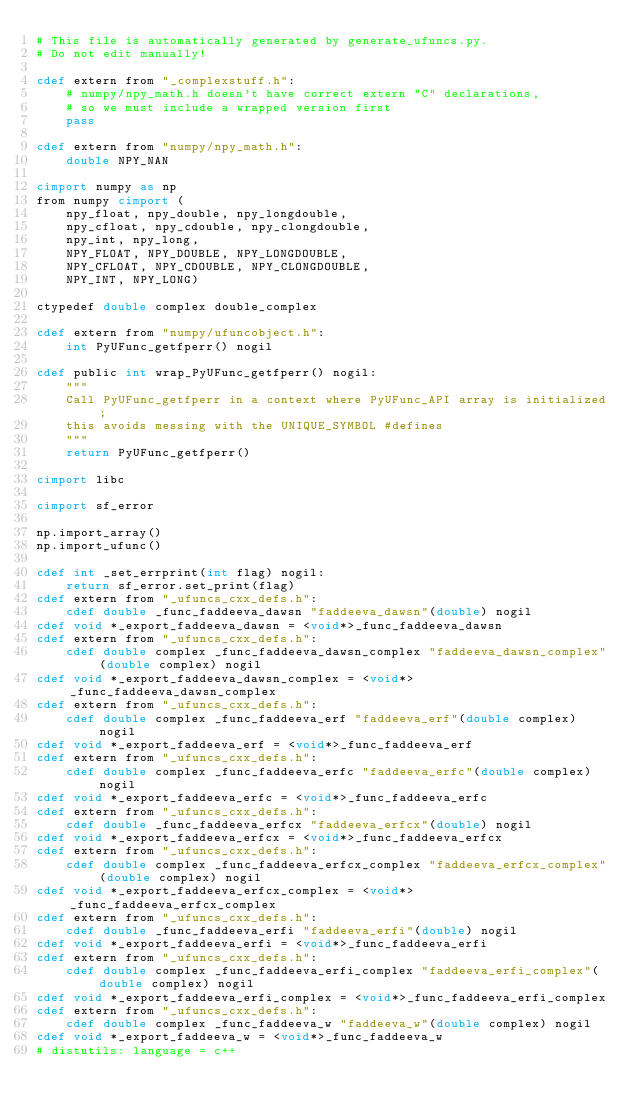<code> <loc_0><loc_0><loc_500><loc_500><_Cython_># This file is automatically generated by generate_ufuncs.py.
# Do not edit manually!

cdef extern from "_complexstuff.h":
    # numpy/npy_math.h doesn't have correct extern "C" declarations,
    # so we must include a wrapped version first
    pass

cdef extern from "numpy/npy_math.h":
    double NPY_NAN

cimport numpy as np
from numpy cimport (
    npy_float, npy_double, npy_longdouble,
    npy_cfloat, npy_cdouble, npy_clongdouble,
    npy_int, npy_long,
    NPY_FLOAT, NPY_DOUBLE, NPY_LONGDOUBLE,
    NPY_CFLOAT, NPY_CDOUBLE, NPY_CLONGDOUBLE,
    NPY_INT, NPY_LONG)

ctypedef double complex double_complex

cdef extern from "numpy/ufuncobject.h":
    int PyUFunc_getfperr() nogil

cdef public int wrap_PyUFunc_getfperr() nogil:
    """
    Call PyUFunc_getfperr in a context where PyUFunc_API array is initialized;
    this avoids messing with the UNIQUE_SYMBOL #defines
    """
    return PyUFunc_getfperr()

cimport libc

cimport sf_error

np.import_array()
np.import_ufunc()

cdef int _set_errprint(int flag) nogil:
    return sf_error.set_print(flag)
cdef extern from "_ufuncs_cxx_defs.h":
    cdef double _func_faddeeva_dawsn "faddeeva_dawsn"(double) nogil
cdef void *_export_faddeeva_dawsn = <void*>_func_faddeeva_dawsn
cdef extern from "_ufuncs_cxx_defs.h":
    cdef double complex _func_faddeeva_dawsn_complex "faddeeva_dawsn_complex"(double complex) nogil
cdef void *_export_faddeeva_dawsn_complex = <void*>_func_faddeeva_dawsn_complex
cdef extern from "_ufuncs_cxx_defs.h":
    cdef double complex _func_faddeeva_erf "faddeeva_erf"(double complex) nogil
cdef void *_export_faddeeva_erf = <void*>_func_faddeeva_erf
cdef extern from "_ufuncs_cxx_defs.h":
    cdef double complex _func_faddeeva_erfc "faddeeva_erfc"(double complex) nogil
cdef void *_export_faddeeva_erfc = <void*>_func_faddeeva_erfc
cdef extern from "_ufuncs_cxx_defs.h":
    cdef double _func_faddeeva_erfcx "faddeeva_erfcx"(double) nogil
cdef void *_export_faddeeva_erfcx = <void*>_func_faddeeva_erfcx
cdef extern from "_ufuncs_cxx_defs.h":
    cdef double complex _func_faddeeva_erfcx_complex "faddeeva_erfcx_complex"(double complex) nogil
cdef void *_export_faddeeva_erfcx_complex = <void*>_func_faddeeva_erfcx_complex
cdef extern from "_ufuncs_cxx_defs.h":
    cdef double _func_faddeeva_erfi "faddeeva_erfi"(double) nogil
cdef void *_export_faddeeva_erfi = <void*>_func_faddeeva_erfi
cdef extern from "_ufuncs_cxx_defs.h":
    cdef double complex _func_faddeeva_erfi_complex "faddeeva_erfi_complex"(double complex) nogil
cdef void *_export_faddeeva_erfi_complex = <void*>_func_faddeeva_erfi_complex
cdef extern from "_ufuncs_cxx_defs.h":
    cdef double complex _func_faddeeva_w "faddeeva_w"(double complex) nogil
cdef void *_export_faddeeva_w = <void*>_func_faddeeva_w
# distutils: language = c++
</code> 